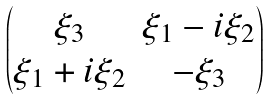Convert formula to latex. <formula><loc_0><loc_0><loc_500><loc_500>\begin{pmatrix} \xi _ { 3 } & \xi _ { 1 } - i \xi _ { 2 } \\ \xi _ { 1 } + i \xi _ { 2 } & - \xi _ { 3 } \end{pmatrix}</formula> 